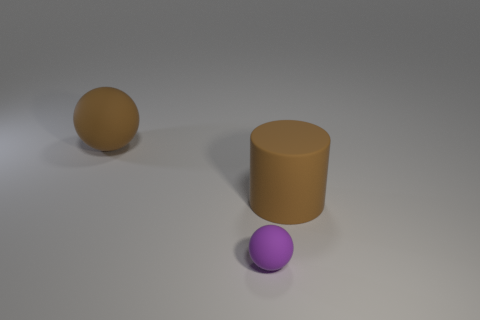Add 1 small green metal things. How many objects exist? 4 Subtract all balls. How many objects are left? 1 Subtract all purple spheres. How many spheres are left? 1 Subtract all small rubber spheres. Subtract all blue blocks. How many objects are left? 2 Add 3 big brown rubber objects. How many big brown rubber objects are left? 5 Add 3 blue cylinders. How many blue cylinders exist? 3 Subtract 0 blue cylinders. How many objects are left? 3 Subtract all blue cylinders. Subtract all cyan balls. How many cylinders are left? 1 